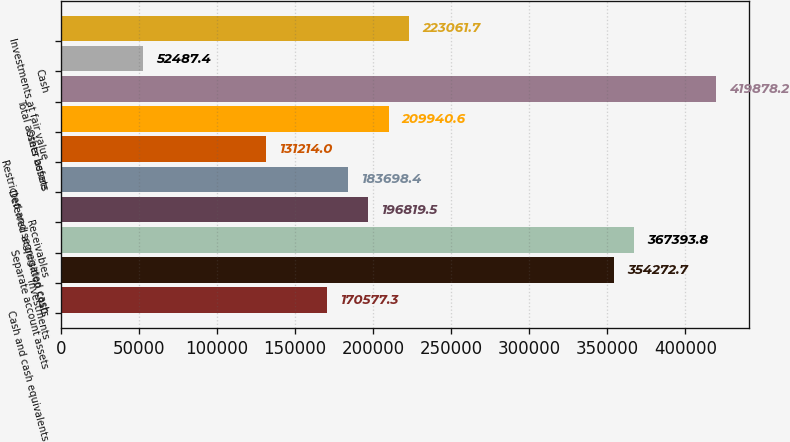<chart> <loc_0><loc_0><loc_500><loc_500><bar_chart><fcel>Cash and cash equivalents<fcel>Investments<fcel>Separate account assets<fcel>Receivables<fcel>Deferred acquisition costs<fcel>Restricted and segregated cash<fcel>Other assets<fcel>Total assets before<fcel>Cash<fcel>Investments at fair value<nl><fcel>170577<fcel>354273<fcel>367394<fcel>196820<fcel>183698<fcel>131214<fcel>209941<fcel>419878<fcel>52487.4<fcel>223062<nl></chart> 